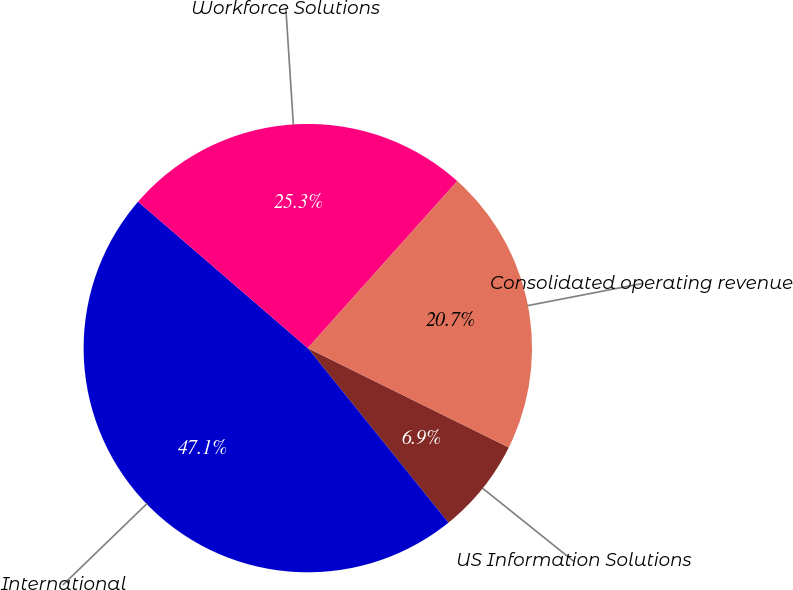<chart> <loc_0><loc_0><loc_500><loc_500><pie_chart><fcel>US Information Solutions<fcel>International<fcel>Workforce Solutions<fcel>Consolidated operating revenue<nl><fcel>6.9%<fcel>47.13%<fcel>25.29%<fcel>20.69%<nl></chart> 